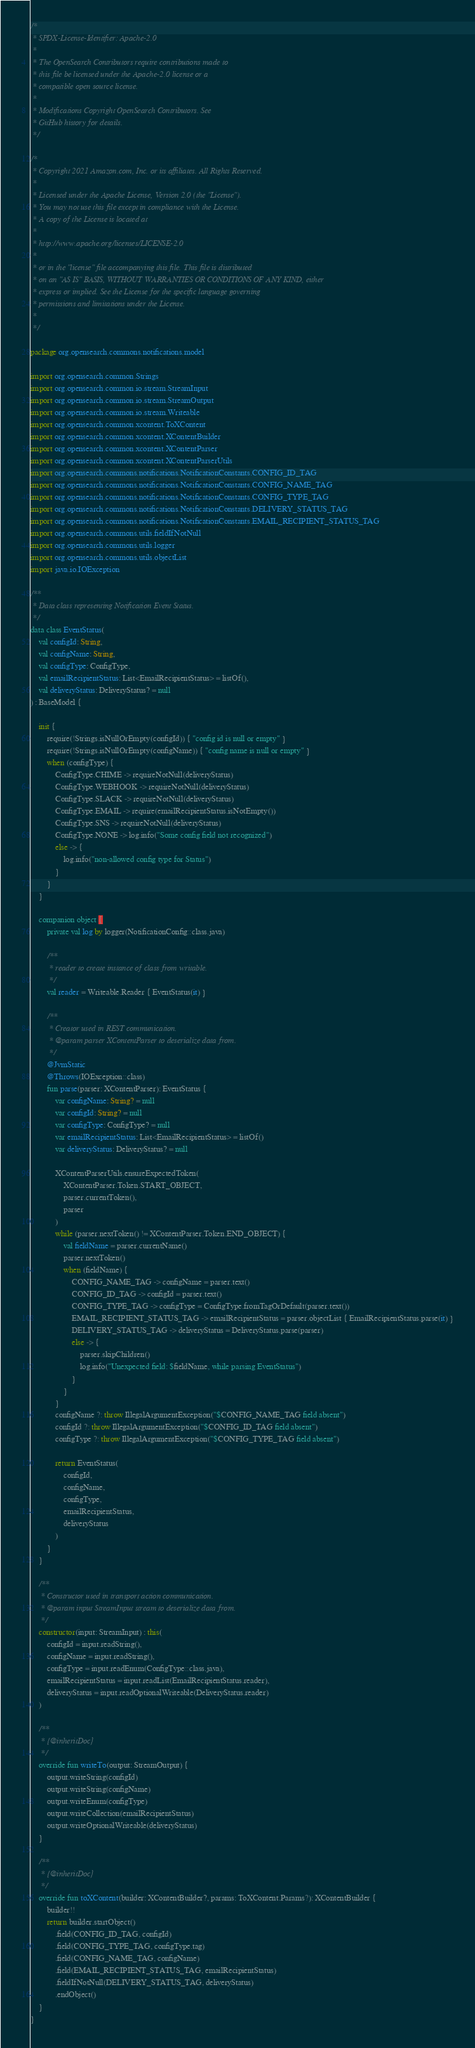Convert code to text. <code><loc_0><loc_0><loc_500><loc_500><_Kotlin_>/*
 * SPDX-License-Identifier: Apache-2.0
 *
 * The OpenSearch Contributors require contributions made to
 * this file be licensed under the Apache-2.0 license or a
 * compatible open source license.
 *
 * Modifications Copyright OpenSearch Contributors. See
 * GitHub history for details.
 */

/*
 * Copyright 2021 Amazon.com, Inc. or its affiliates. All Rights Reserved.
 *
 * Licensed under the Apache License, Version 2.0 (the "License").
 * You may not use this file except in compliance with the License.
 * A copy of the License is located at
 *
 * http://www.apache.org/licenses/LICENSE-2.0
 *
 * or in the "license" file accompanying this file. This file is distributed
 * on an "AS IS" BASIS, WITHOUT WARRANTIES OR CONDITIONS OF ANY KIND, either
 * express or implied. See the License for the specific language governing
 * permissions and limitations under the License.
 *
 */

package org.opensearch.commons.notifications.model

import org.opensearch.common.Strings
import org.opensearch.common.io.stream.StreamInput
import org.opensearch.common.io.stream.StreamOutput
import org.opensearch.common.io.stream.Writeable
import org.opensearch.common.xcontent.ToXContent
import org.opensearch.common.xcontent.XContentBuilder
import org.opensearch.common.xcontent.XContentParser
import org.opensearch.common.xcontent.XContentParserUtils
import org.opensearch.commons.notifications.NotificationConstants.CONFIG_ID_TAG
import org.opensearch.commons.notifications.NotificationConstants.CONFIG_NAME_TAG
import org.opensearch.commons.notifications.NotificationConstants.CONFIG_TYPE_TAG
import org.opensearch.commons.notifications.NotificationConstants.DELIVERY_STATUS_TAG
import org.opensearch.commons.notifications.NotificationConstants.EMAIL_RECIPIENT_STATUS_TAG
import org.opensearch.commons.utils.fieldIfNotNull
import org.opensearch.commons.utils.logger
import org.opensearch.commons.utils.objectList
import java.io.IOException

/**
 * Data class representing Notification Event Status.
 */
data class EventStatus(
    val configId: String,
    val configName: String,
    val configType: ConfigType,
    val emailRecipientStatus: List<EmailRecipientStatus> = listOf(),
    val deliveryStatus: DeliveryStatus? = null
) : BaseModel {

    init {
        require(!Strings.isNullOrEmpty(configId)) { "config id is null or empty" }
        require(!Strings.isNullOrEmpty(configName)) { "config name is null or empty" }
        when (configType) {
            ConfigType.CHIME -> requireNotNull(deliveryStatus)
            ConfigType.WEBHOOK -> requireNotNull(deliveryStatus)
            ConfigType.SLACK -> requireNotNull(deliveryStatus)
            ConfigType.EMAIL -> require(emailRecipientStatus.isNotEmpty())
            ConfigType.SNS -> requireNotNull(deliveryStatus)
            ConfigType.NONE -> log.info("Some config field not recognized")
            else -> {
                log.info("non-allowed config type for Status")
            }
        }
    }

    companion object {
        private val log by logger(NotificationConfig::class.java)

        /**
         * reader to create instance of class from writable.
         */
        val reader = Writeable.Reader { EventStatus(it) }

        /**
         * Creator used in REST communication.
         * @param parser XContentParser to deserialize data from.
         */
        @JvmStatic
        @Throws(IOException::class)
        fun parse(parser: XContentParser): EventStatus {
            var configName: String? = null
            var configId: String? = null
            var configType: ConfigType? = null
            var emailRecipientStatus: List<EmailRecipientStatus> = listOf()
            var deliveryStatus: DeliveryStatus? = null

            XContentParserUtils.ensureExpectedToken(
                XContentParser.Token.START_OBJECT,
                parser.currentToken(),
                parser
            )
            while (parser.nextToken() != XContentParser.Token.END_OBJECT) {
                val fieldName = parser.currentName()
                parser.nextToken()
                when (fieldName) {
                    CONFIG_NAME_TAG -> configName = parser.text()
                    CONFIG_ID_TAG -> configId = parser.text()
                    CONFIG_TYPE_TAG -> configType = ConfigType.fromTagOrDefault(parser.text())
                    EMAIL_RECIPIENT_STATUS_TAG -> emailRecipientStatus = parser.objectList { EmailRecipientStatus.parse(it) }
                    DELIVERY_STATUS_TAG -> deliveryStatus = DeliveryStatus.parse(parser)
                    else -> {
                        parser.skipChildren()
                        log.info("Unexpected field: $fieldName, while parsing EventStatus")
                    }
                }
            }
            configName ?: throw IllegalArgumentException("$CONFIG_NAME_TAG field absent")
            configId ?: throw IllegalArgumentException("$CONFIG_ID_TAG field absent")
            configType ?: throw IllegalArgumentException("$CONFIG_TYPE_TAG field absent")

            return EventStatus(
                configId,
                configName,
                configType,
                emailRecipientStatus,
                deliveryStatus
            )
        }
    }

    /**
     * Constructor used in transport action communication.
     * @param input StreamInput stream to deserialize data from.
     */
    constructor(input: StreamInput) : this(
        configId = input.readString(),
        configName = input.readString(),
        configType = input.readEnum(ConfigType::class.java),
        emailRecipientStatus = input.readList(EmailRecipientStatus.reader),
        deliveryStatus = input.readOptionalWriteable(DeliveryStatus.reader)
    )

    /**
     * {@inheritDoc}
     */
    override fun writeTo(output: StreamOutput) {
        output.writeString(configId)
        output.writeString(configName)
        output.writeEnum(configType)
        output.writeCollection(emailRecipientStatus)
        output.writeOptionalWriteable(deliveryStatus)
    }

    /**
     * {@inheritDoc}
     */
    override fun toXContent(builder: XContentBuilder?, params: ToXContent.Params?): XContentBuilder {
        builder!!
        return builder.startObject()
            .field(CONFIG_ID_TAG, configId)
            .field(CONFIG_TYPE_TAG, configType.tag)
            .field(CONFIG_NAME_TAG, configName)
            .field(EMAIL_RECIPIENT_STATUS_TAG, emailRecipientStatus)
            .fieldIfNotNull(DELIVERY_STATUS_TAG, deliveryStatus)
            .endObject()
    }
}
</code> 